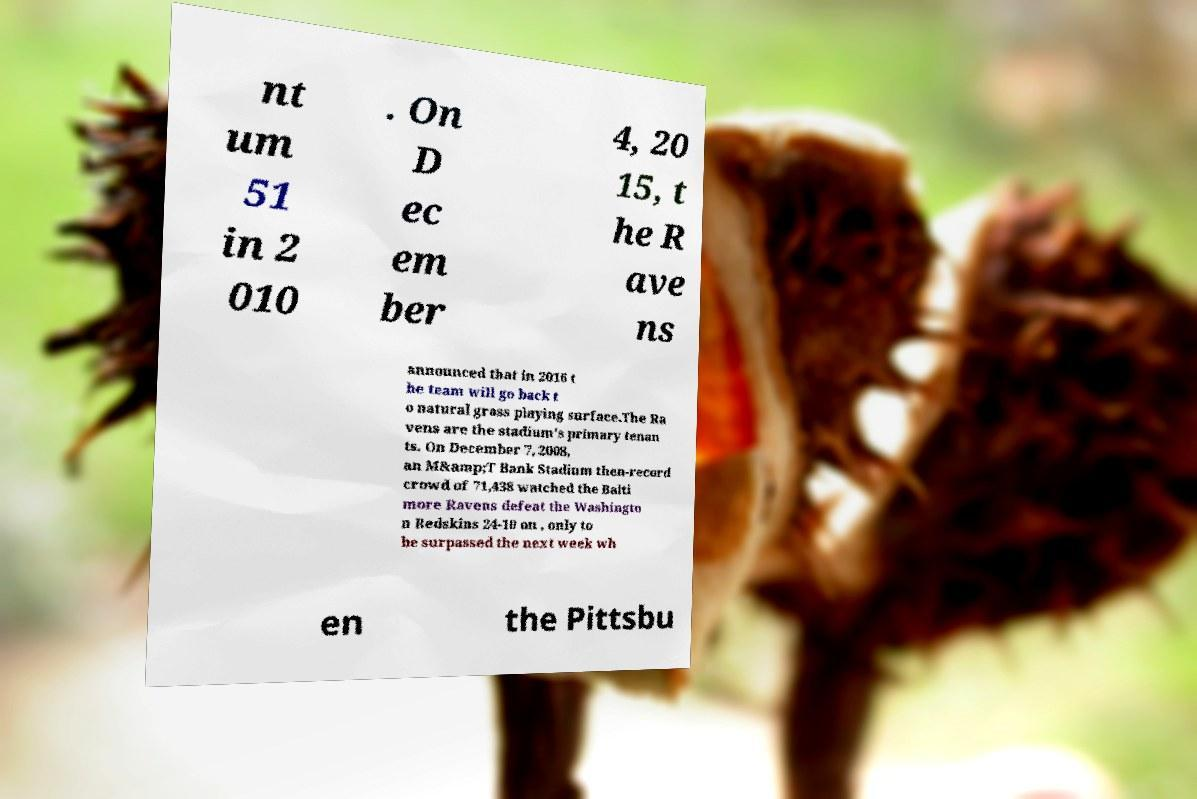For documentation purposes, I need the text within this image transcribed. Could you provide that? nt um 51 in 2 010 . On D ec em ber 4, 20 15, t he R ave ns announced that in 2016 t he team will go back t o natural grass playing surface.The Ra vens are the stadium's primary tenan ts. On December 7, 2008, an M&amp;T Bank Stadium then-record crowd of 71,438 watched the Balti more Ravens defeat the Washingto n Redskins 24-10 on , only to be surpassed the next week wh en the Pittsbu 